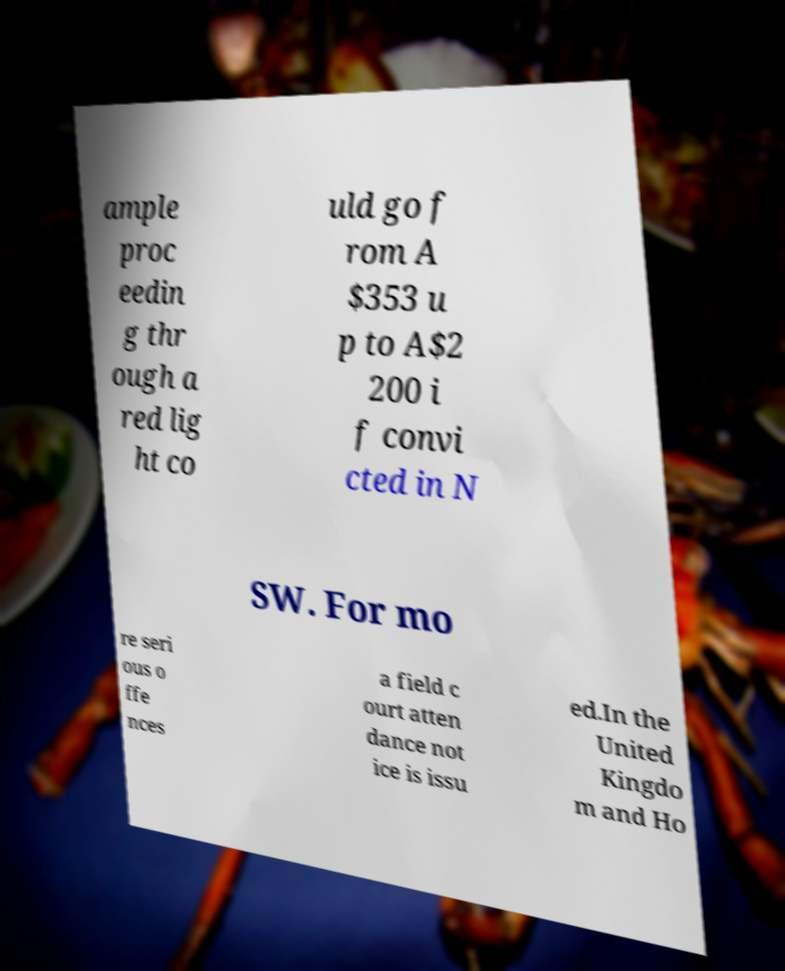Could you extract and type out the text from this image? ample proc eedin g thr ough a red lig ht co uld go f rom A $353 u p to A$2 200 i f convi cted in N SW. For mo re seri ous o ffe nces a field c ourt atten dance not ice is issu ed.In the United Kingdo m and Ho 